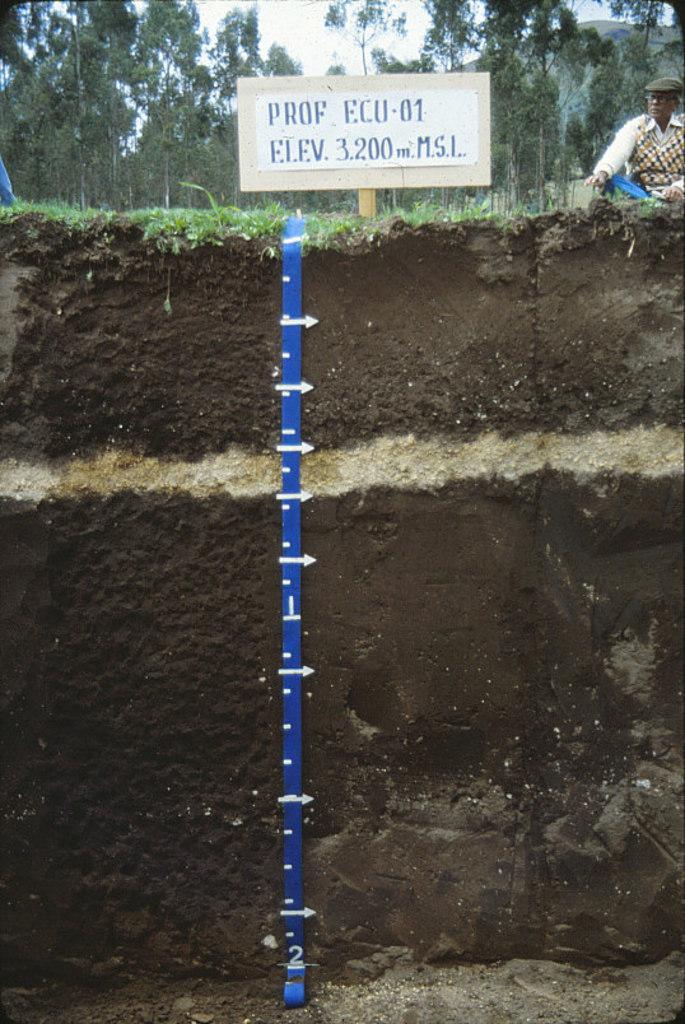Can you describe this image briefly? In this image we can see layers of soil and a measuring tool. At the top of the image there is grass, name board, person, trees, sky and other objects. At the bottom of the image there is the ground. 